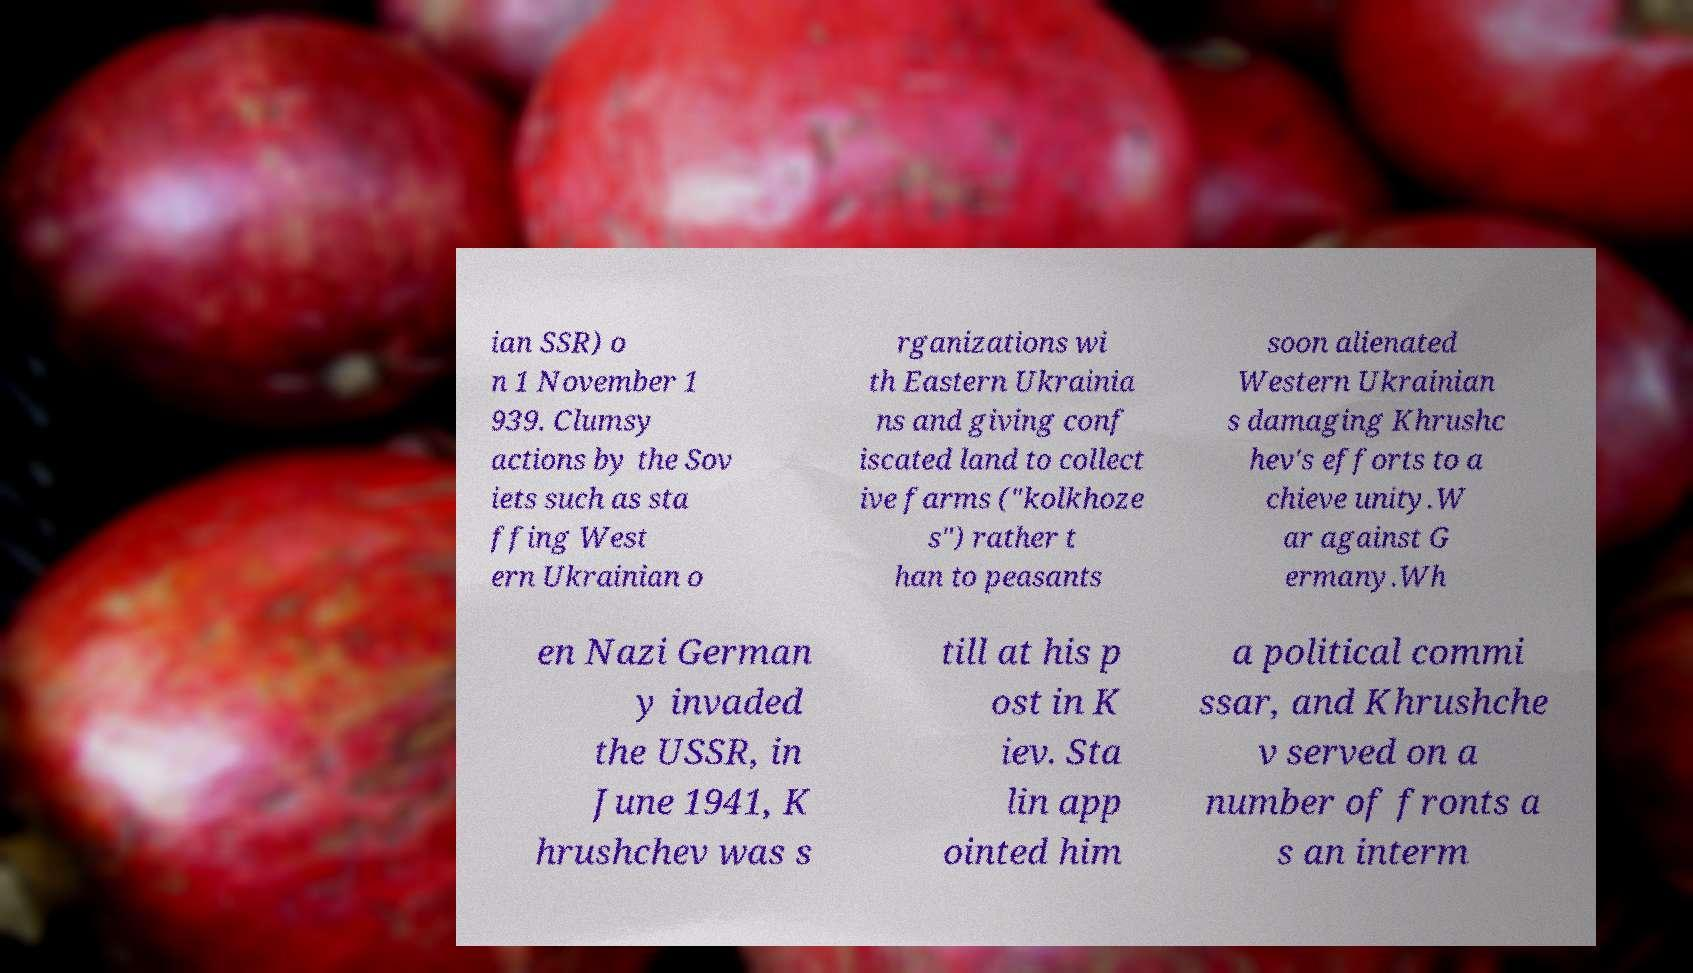Could you extract and type out the text from this image? ian SSR) o n 1 November 1 939. Clumsy actions by the Sov iets such as sta ffing West ern Ukrainian o rganizations wi th Eastern Ukrainia ns and giving conf iscated land to collect ive farms ("kolkhoze s") rather t han to peasants soon alienated Western Ukrainian s damaging Khrushc hev's efforts to a chieve unity.W ar against G ermany.Wh en Nazi German y invaded the USSR, in June 1941, K hrushchev was s till at his p ost in K iev. Sta lin app ointed him a political commi ssar, and Khrushche v served on a number of fronts a s an interm 